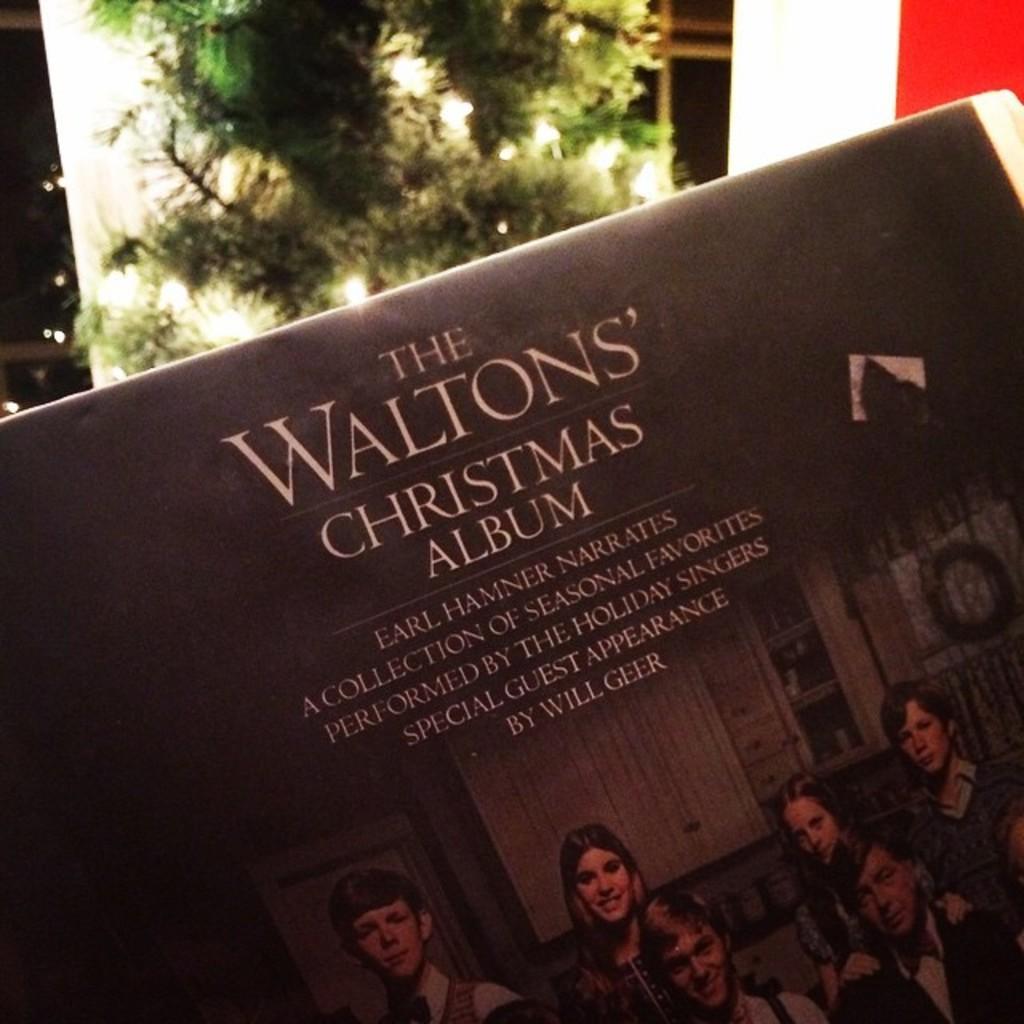How would you summarize this image in a sentence or two? In this image we can see a picture of few persons and texts written on a board. In the background there is a plant and objects. 